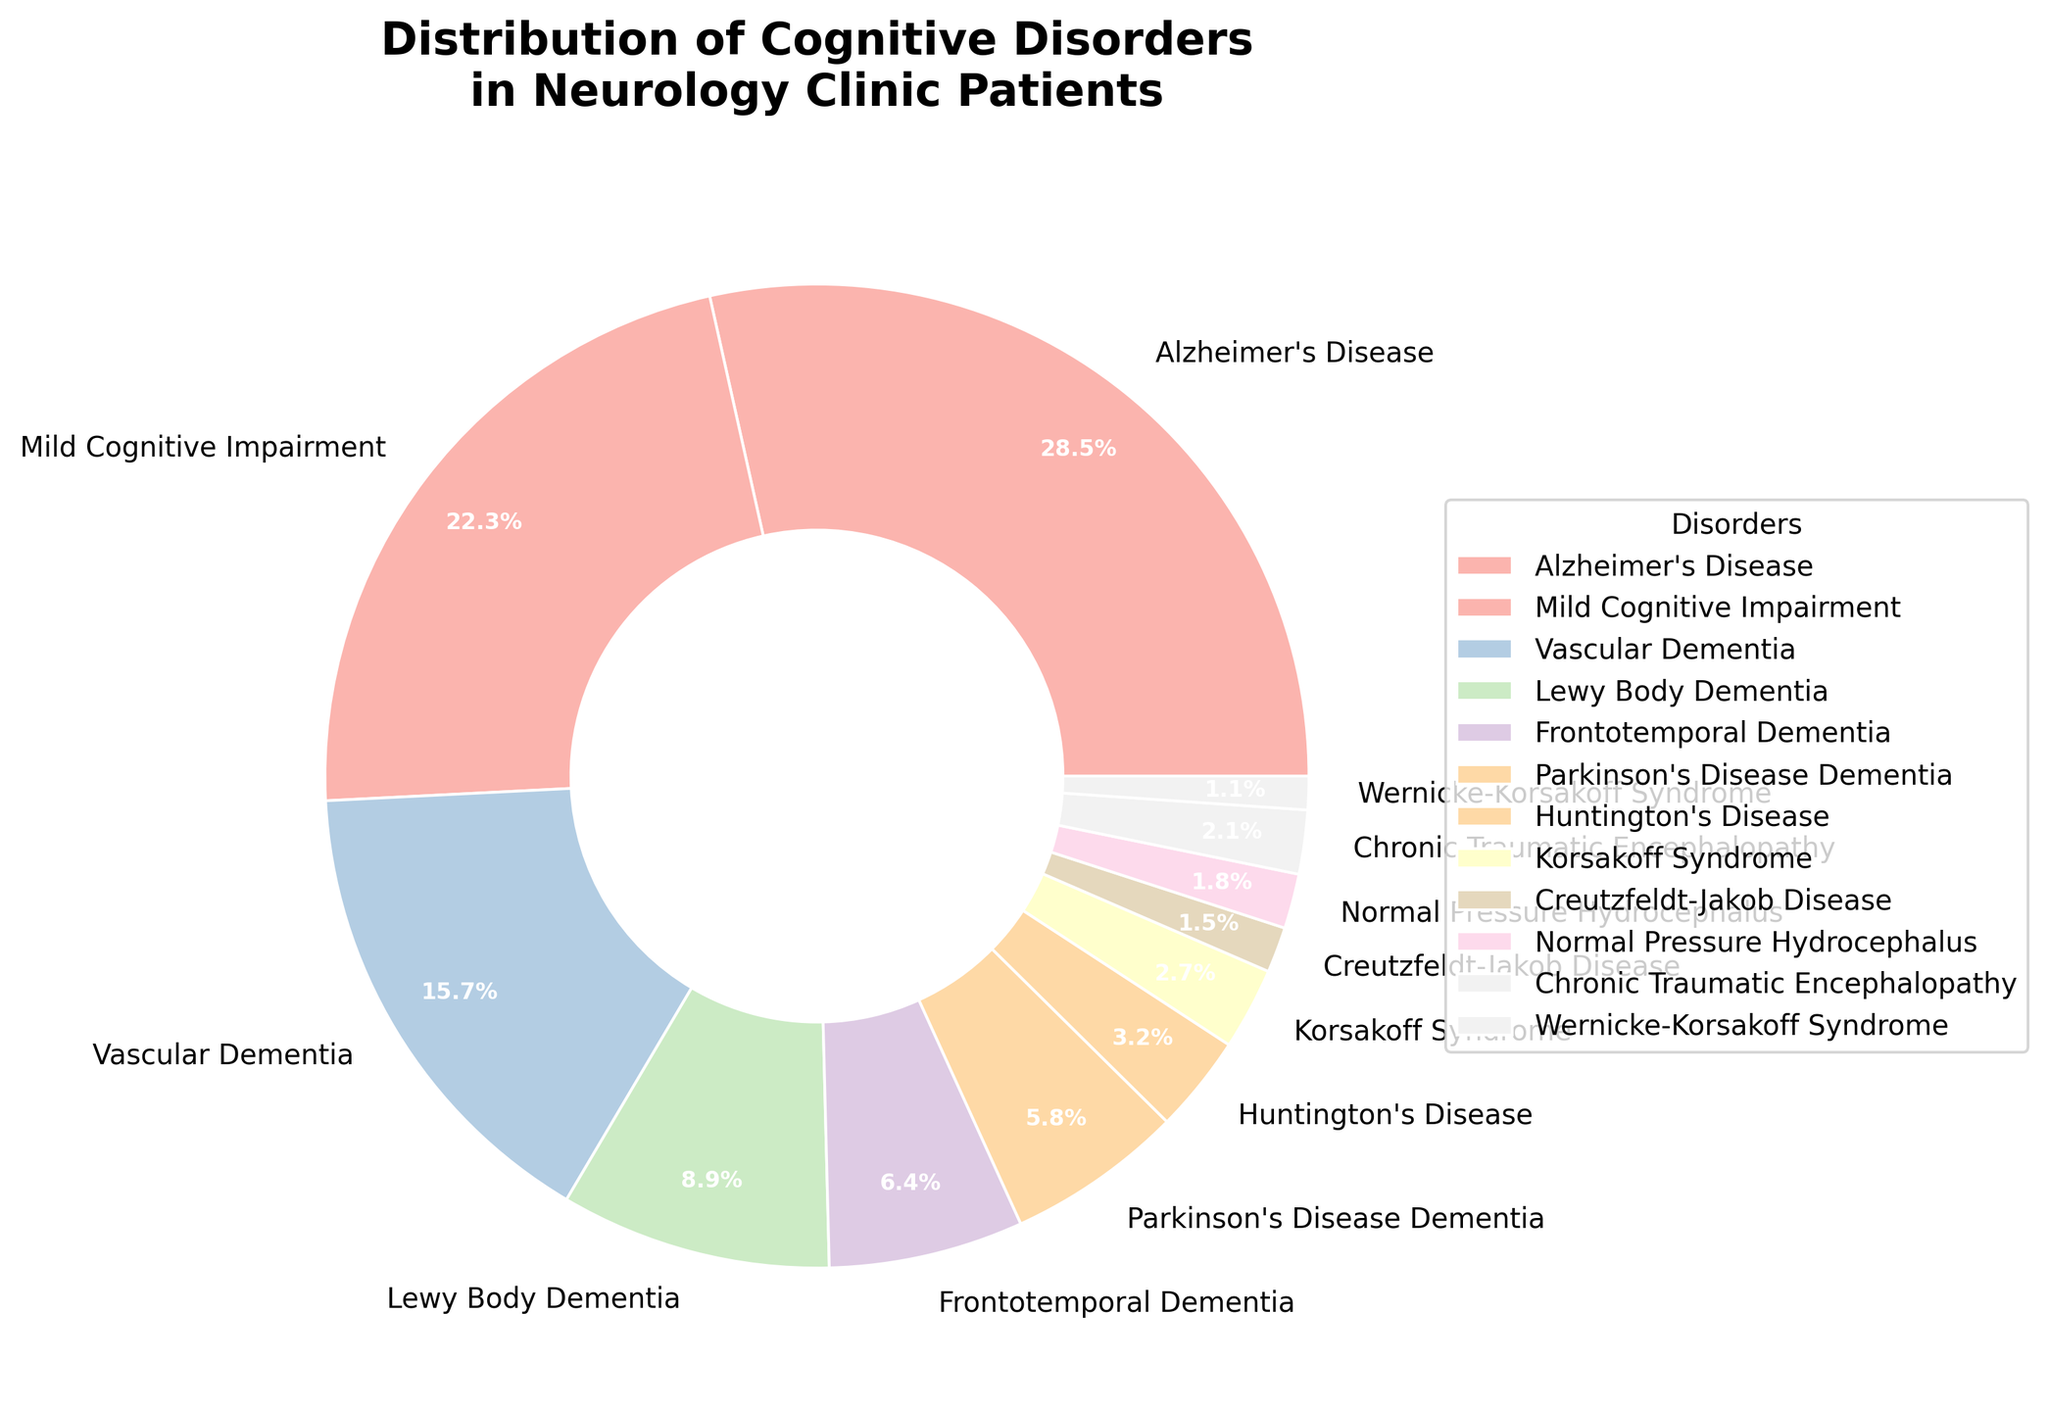What percentage of patients have Alzheimer's Disease? Look at the section of the pie chart labeled "Alzheimer's Disease". The percentage shown is 28.5%
Answer: 28.5% Which disorder has the second highest percentage of patients? The disorder with the second largest section of the pie chart is "Mild Cognitive Impairment" with a percentage of 22.3%
Answer: Mild Cognitive Impairment What is the combined percentage of patients with Vascular Dementia and Lewy Body Dementia? Locate the sections for "Vascular Dementia" and "Lewy Body Dementia". Their percentages are 15.7% and 8.9%, respectively. Sum these percentages: 15.7% + 8.9% = 24.6%
Answer: 24.6% Among the disorders with percentages below 5%, which has the smallest section in the pie chart? Identify the disorders with percentages below 5%. The smallest section of these is "Wernicke-Korsakoff Syndrome" with 1.1%
Answer: Wernicke-Korsakoff Syndrome Is the combined percentage of patients with Frontotemporal Dementia and Parkinson's Disease Dementia greater than the percentage of those with Mild Cognitive Impairment? Sum the percentages for "Frontotemporal Dementia" and "Parkinson's Disease Dementia": 6.4% + 5.8% = 12.2%. Compare this with the percentage for "Mild Cognitive Impairment" which is 22.3%. 12.2% is less than 22.3%
Answer: No What is the percentage difference between Huntington's Disease and Korsakoff Syndrome? Locate the sections for "Huntington's Disease" and "Korsakoff Syndrome". Their percentages are 3.2% and 2.7%, respectively. The difference is 3.2% - 2.7% = 0.5%
Answer: 0.5% Which disorder is represented by the lightest color in the pie chart? Looking at the pie chart, the pastel color scheme tends to have lighter colors towards the lower proportions. "Wernicke-Korsakoff Syndrome" has the smallest percentage and typically a lighter color
Answer: Wernicke-Korsakoff Syndrome How many disorders have a percentage between 1% and 3%? Identify the sections of the pie chart with percentages between 1% and 3%. These disorders are "Huntington's Disease" (3.2%), "Korsakoff Syndrome" (2.7%), "Chronic Traumatic Encephalopathy" (2.1%), "Creutzfeldt-Jakob Disease" (1.5%), and "Normal Pressure Hydrocephalus" (1.8%). There are 5 such disorders
Answer: 5 What is the numerical difference between the percentage of patients with Alzheimer's Disease and the combined percentage of patients with both Vascular Dementia and Lewy Body Dementia? Percentage for Alzheimer's Disease is 28.5%. Sum the percentages for Vascular Dementia (15.7%) and Lewy Body Dementia (8.9%): 15.7% + 8.9% = 24.6%. The difference is 28.5% - 24.6% = 3.9%
Answer: 3.9% 